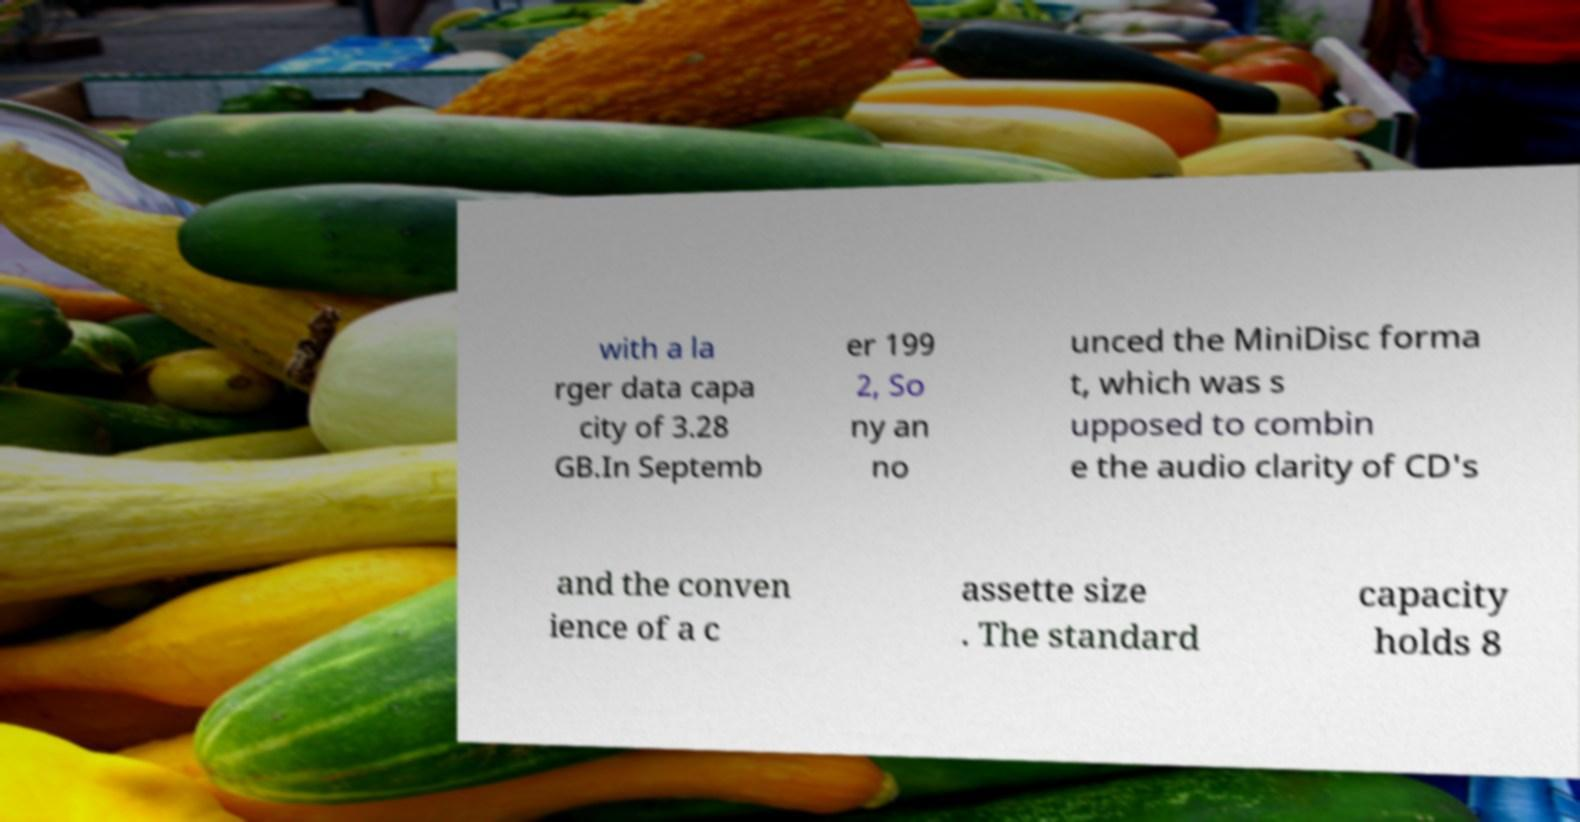For documentation purposes, I need the text within this image transcribed. Could you provide that? with a la rger data capa city of 3.28 GB.In Septemb er 199 2, So ny an no unced the MiniDisc forma t, which was s upposed to combin e the audio clarity of CD's and the conven ience of a c assette size . The standard capacity holds 8 